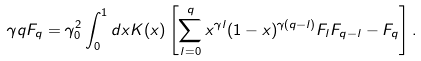<formula> <loc_0><loc_0><loc_500><loc_500>\gamma q F _ { q } = \gamma _ { 0 } ^ { 2 } \int _ { 0 } ^ { 1 } d x K ( x ) \left [ \sum _ { l = 0 } ^ { q } x ^ { \gamma l } ( 1 - x ) ^ { \gamma ( q - l ) } F _ { l } F _ { q - l } - F _ { q } \right ] .</formula> 